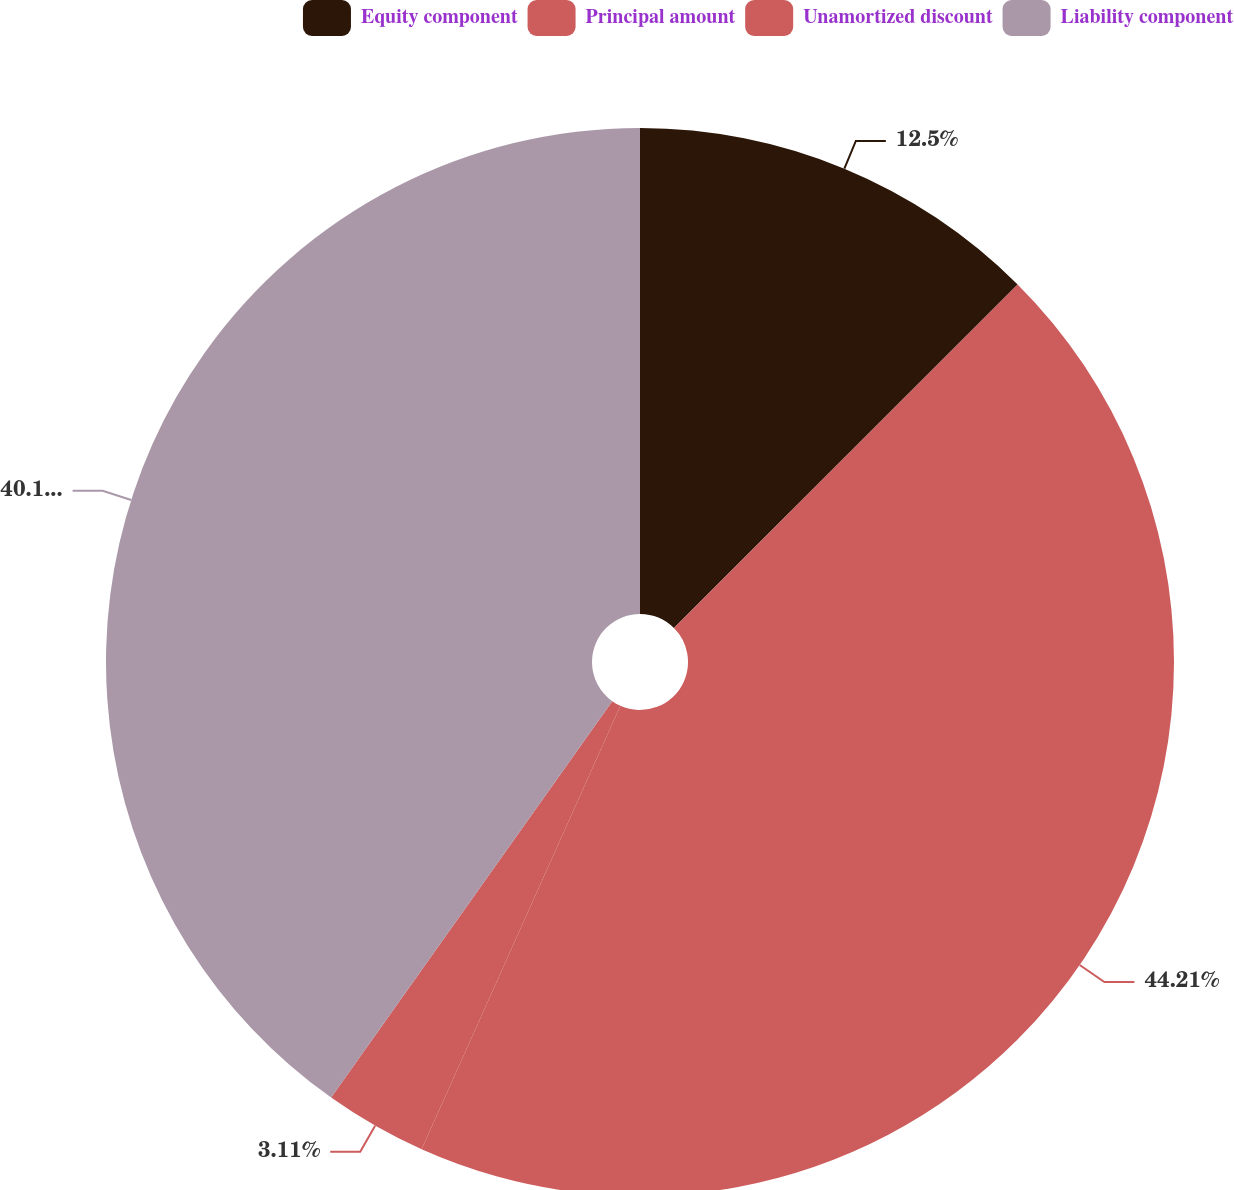<chart> <loc_0><loc_0><loc_500><loc_500><pie_chart><fcel>Equity component<fcel>Principal amount<fcel>Unamortized discount<fcel>Liability component<nl><fcel>12.5%<fcel>44.2%<fcel>3.11%<fcel>40.18%<nl></chart> 